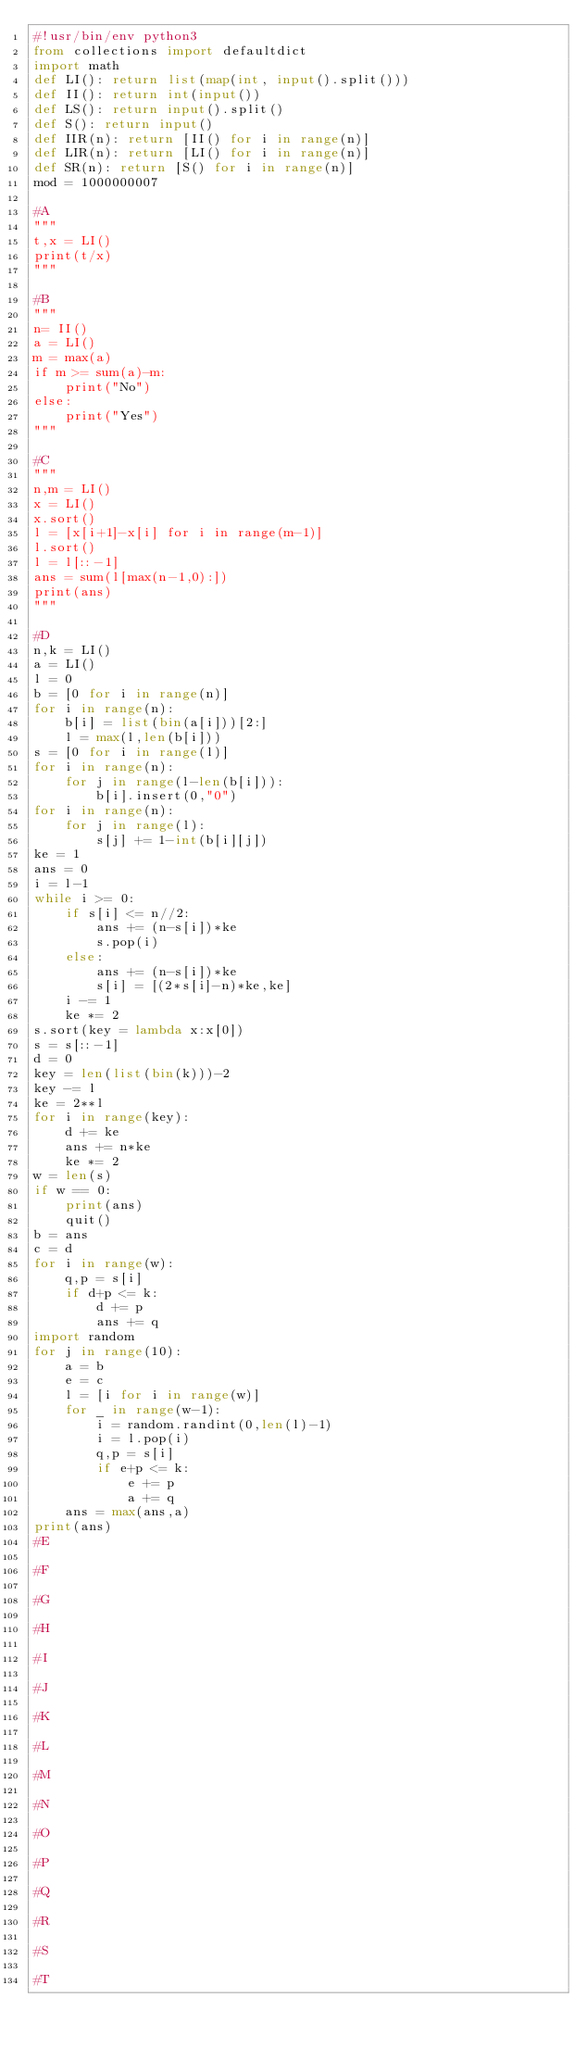Convert code to text. <code><loc_0><loc_0><loc_500><loc_500><_Python_>#!usr/bin/env python3
from collections import defaultdict
import math
def LI(): return list(map(int, input().split()))
def II(): return int(input())
def LS(): return input().split()
def S(): return input()
def IIR(n): return [II() for i in range(n)]
def LIR(n): return [LI() for i in range(n)]
def SR(n): return [S() for i in range(n)]
mod = 1000000007

#A
"""
t,x = LI()
print(t/x)
"""

#B
"""
n= II()
a = LI()
m = max(a)
if m >= sum(a)-m:
    print("No")
else:
    print("Yes")
"""

#C
"""
n,m = LI()
x = LI()
x.sort()
l = [x[i+1]-x[i] for i in range(m-1)]
l.sort()
l = l[::-1]
ans = sum(l[max(n-1,0):])
print(ans)
"""

#D
n,k = LI()
a = LI()
l = 0
b = [0 for i in range(n)]
for i in range(n):
    b[i] = list(bin(a[i]))[2:]
    l = max(l,len(b[i]))
s = [0 for i in range(l)]
for i in range(n):
    for j in range(l-len(b[i])):
        b[i].insert(0,"0")
for i in range(n):
    for j in range(l):
        s[j] += 1-int(b[i][j])
ke = 1
ans = 0
i = l-1
while i >= 0:
    if s[i] <= n//2:
        ans += (n-s[i])*ke
        s.pop(i)
    else:
        ans += (n-s[i])*ke
        s[i] = [(2*s[i]-n)*ke,ke]
    i -= 1
    ke *= 2
s.sort(key = lambda x:x[0])
s = s[::-1]
d = 0
key = len(list(bin(k)))-2
key -= l
ke = 2**l
for i in range(key):
    d += ke
    ans += n*ke
    ke *= 2
w = len(s)
if w == 0:
    print(ans)
    quit()
b = ans
c = d
for i in range(w):
    q,p = s[i]
    if d+p <= k:
        d += p
        ans += q
import random
for j in range(10):
    a = b
    e = c
    l = [i for i in range(w)]
    for _ in range(w-1):
        i = random.randint(0,len(l)-1)
        i = l.pop(i)
        q,p = s[i]
        if e+p <= k:
            e += p
            a += q
    ans = max(ans,a)
print(ans)
#E

#F

#G

#H

#I

#J

#K

#L

#M

#N

#O

#P

#Q

#R

#S

#T
</code> 